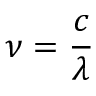<formula> <loc_0><loc_0><loc_500><loc_500>\nu = \frac { c } { \lambda }</formula> 